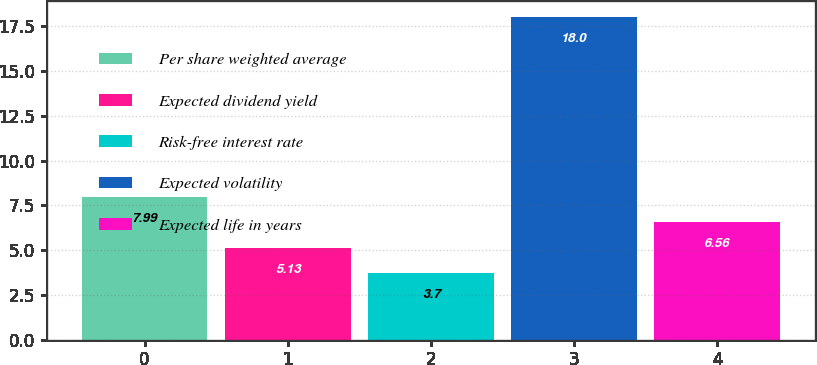Convert chart. <chart><loc_0><loc_0><loc_500><loc_500><bar_chart><fcel>Per share weighted average<fcel>Expected dividend yield<fcel>Risk-free interest rate<fcel>Expected volatility<fcel>Expected life in years<nl><fcel>7.99<fcel>5.13<fcel>3.7<fcel>18<fcel>6.56<nl></chart> 